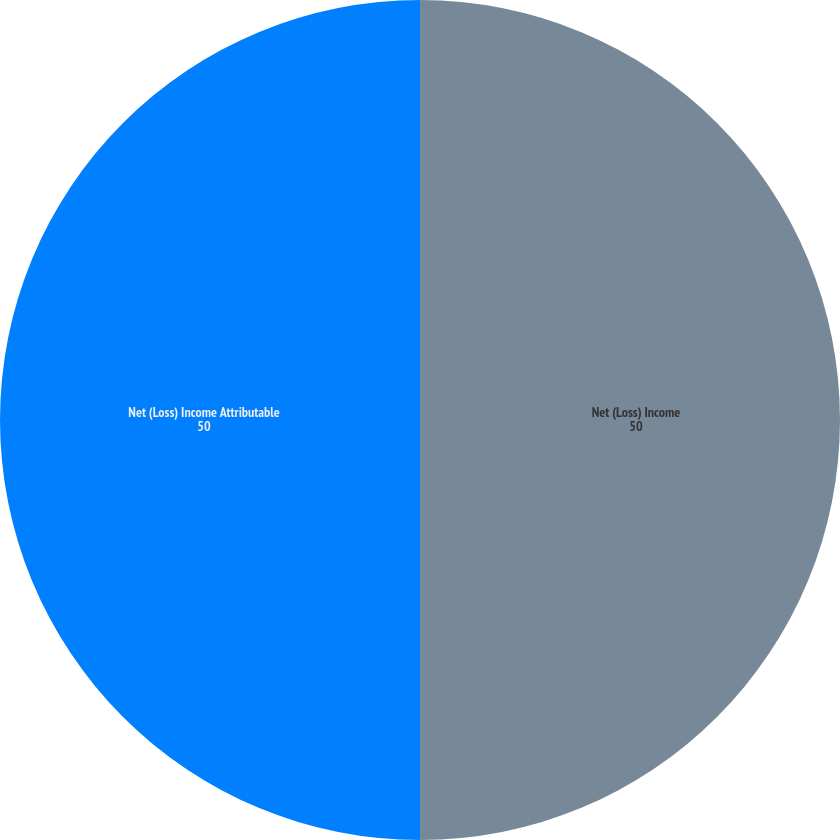Convert chart to OTSL. <chart><loc_0><loc_0><loc_500><loc_500><pie_chart><fcel>Net (Loss) Income<fcel>Net (Loss) Income Attributable<nl><fcel>50.0%<fcel>50.0%<nl></chart> 